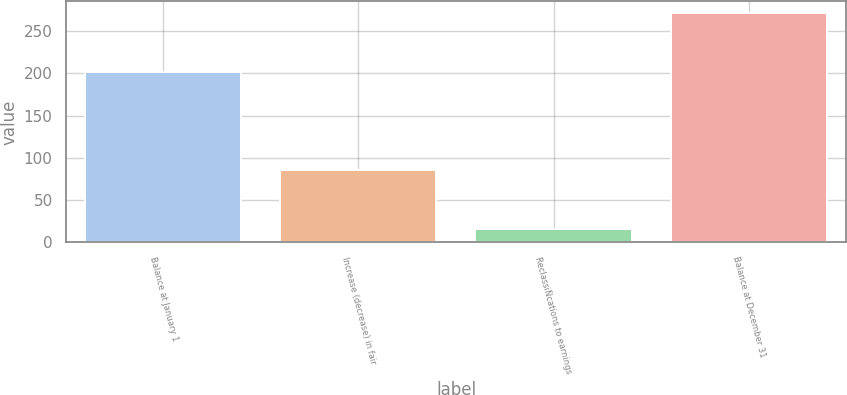Convert chart. <chart><loc_0><loc_0><loc_500><loc_500><bar_chart><fcel>Balance at January 1<fcel>Increase (decrease) in fair<fcel>ReclassiÑcations to earnings<fcel>Balance at December 31<nl><fcel>202<fcel>86<fcel>16<fcel>272<nl></chart> 